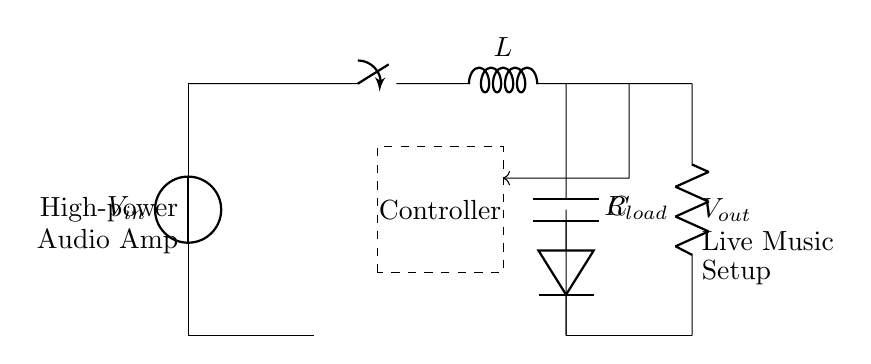What is the input voltage source labeled as? The input voltage source in the circuit diagram is labeled as V in, indicating it is the voltage input to the regulator.
Answer: V in What component provides energy storage in this circuit? The component that provides energy storage in the circuit is the capacitor labeled C, which stores electrical energy and helps smooth the output voltage.
Answer: C What is the purpose of the inductor in this regulator circuit? The inductor, labeled L, is used to store energy temporarily and smooth the current flow, playing a critical role in the switching action of the regulator.
Answer: L How many main components are used in the regulator's conversion process? The main components involved in converting input power to output power in this circuit chain include the switch, inductor, diode, and capacitor, totaling four key components.
Answer: Four What does the dashed rectangle represent? The dashed rectangle represents a controller, which regulates the operation of the switch in the circuit to achieve the desired output voltage.
Answer: Controller What happens to the output voltage when the feedback signal increases? When the feedback signal increases, it indicates that the output voltage is rising above the desired level, prompting the controller to reduce the duty cycle of the switch, which decreases the output voltage.
Answer: Decreases Why is there a diode present in this switching regulator circuit? The diode allows current to flow in one direction, preventing backflow when the switch opens and ensuring that energy can discharge from the inductor to the output load during the switching process.
Answer: To prevent backflow 